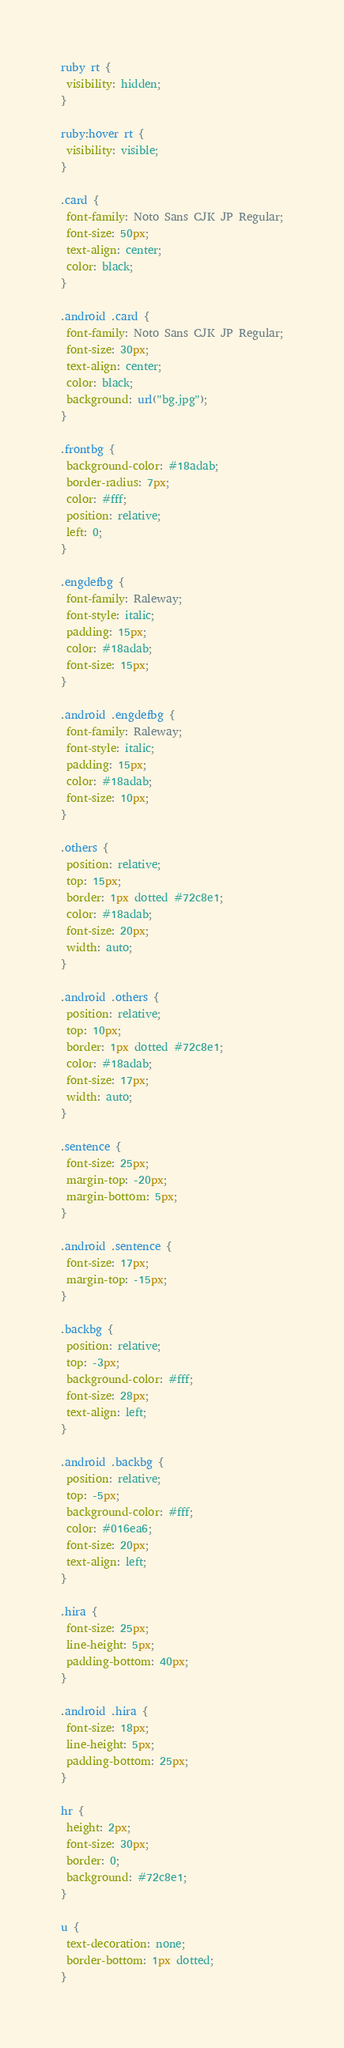Convert code to text. <code><loc_0><loc_0><loc_500><loc_500><_CSS_>ruby rt {
 visibility: hidden;
}

ruby:hover rt {
 visibility: visible;
}

.card {
 font-family: Noto Sans CJK JP Regular;
 font-size: 50px;
 text-align: center;
 color: black;
}

.android .card {
 font-family: Noto Sans CJK JP Regular;
 font-size: 30px;
 text-align: center;
 color: black;
 background: url("bg.jpg");
}

.frontbg {
 background-color: #18adab;
 border-radius: 7px;
 color: #fff;
 position: relative;
 left: 0;
}

.engdefbg {
 font-family: Raleway;
 font-style: italic;
 padding: 15px;
 color: #18adab;
 font-size: 15px;
}

.android .engdefbg {
 font-family: Raleway;
 font-style: italic;
 padding: 15px;
 color: #18adab;
 font-size: 10px;
}

.others {
 position: relative;
 top: 15px;
 border: 1px dotted #72c8e1;
 color: #18adab;
 font-size: 20px;
 width: auto;
}

.android .others {
 position: relative;
 top: 10px;
 border: 1px dotted #72c8e1;
 color: #18adab;
 font-size: 17px;
 width: auto;
}

.sentence {
 font-size: 25px;
 margin-top: -20px;
 margin-bottom: 5px;
}

.android .sentence {
 font-size: 17px;
 margin-top: -15px;
}

.backbg {
 position: relative;
 top: -3px;
 background-color: #fff;
 font-size: 28px;
 text-align: left;
}

.android .backbg {
 position: relative;
 top: -5px;
 background-color: #fff;
 color: #016ea6;
 font-size: 20px;
 text-align: left;
}

.hira {
 font-size: 25px;
 line-height: 5px;
 padding-bottom: 40px;
}

.android .hira {
 font-size: 18px;
 line-height: 5px;
 padding-bottom: 25px;
}

hr {
 height: 2px;
 font-size: 30px;
 border: 0;
 background: #72c8e1;
}

u {
 text-decoration: none;
 border-bottom: 1px dotted;
}</code> 